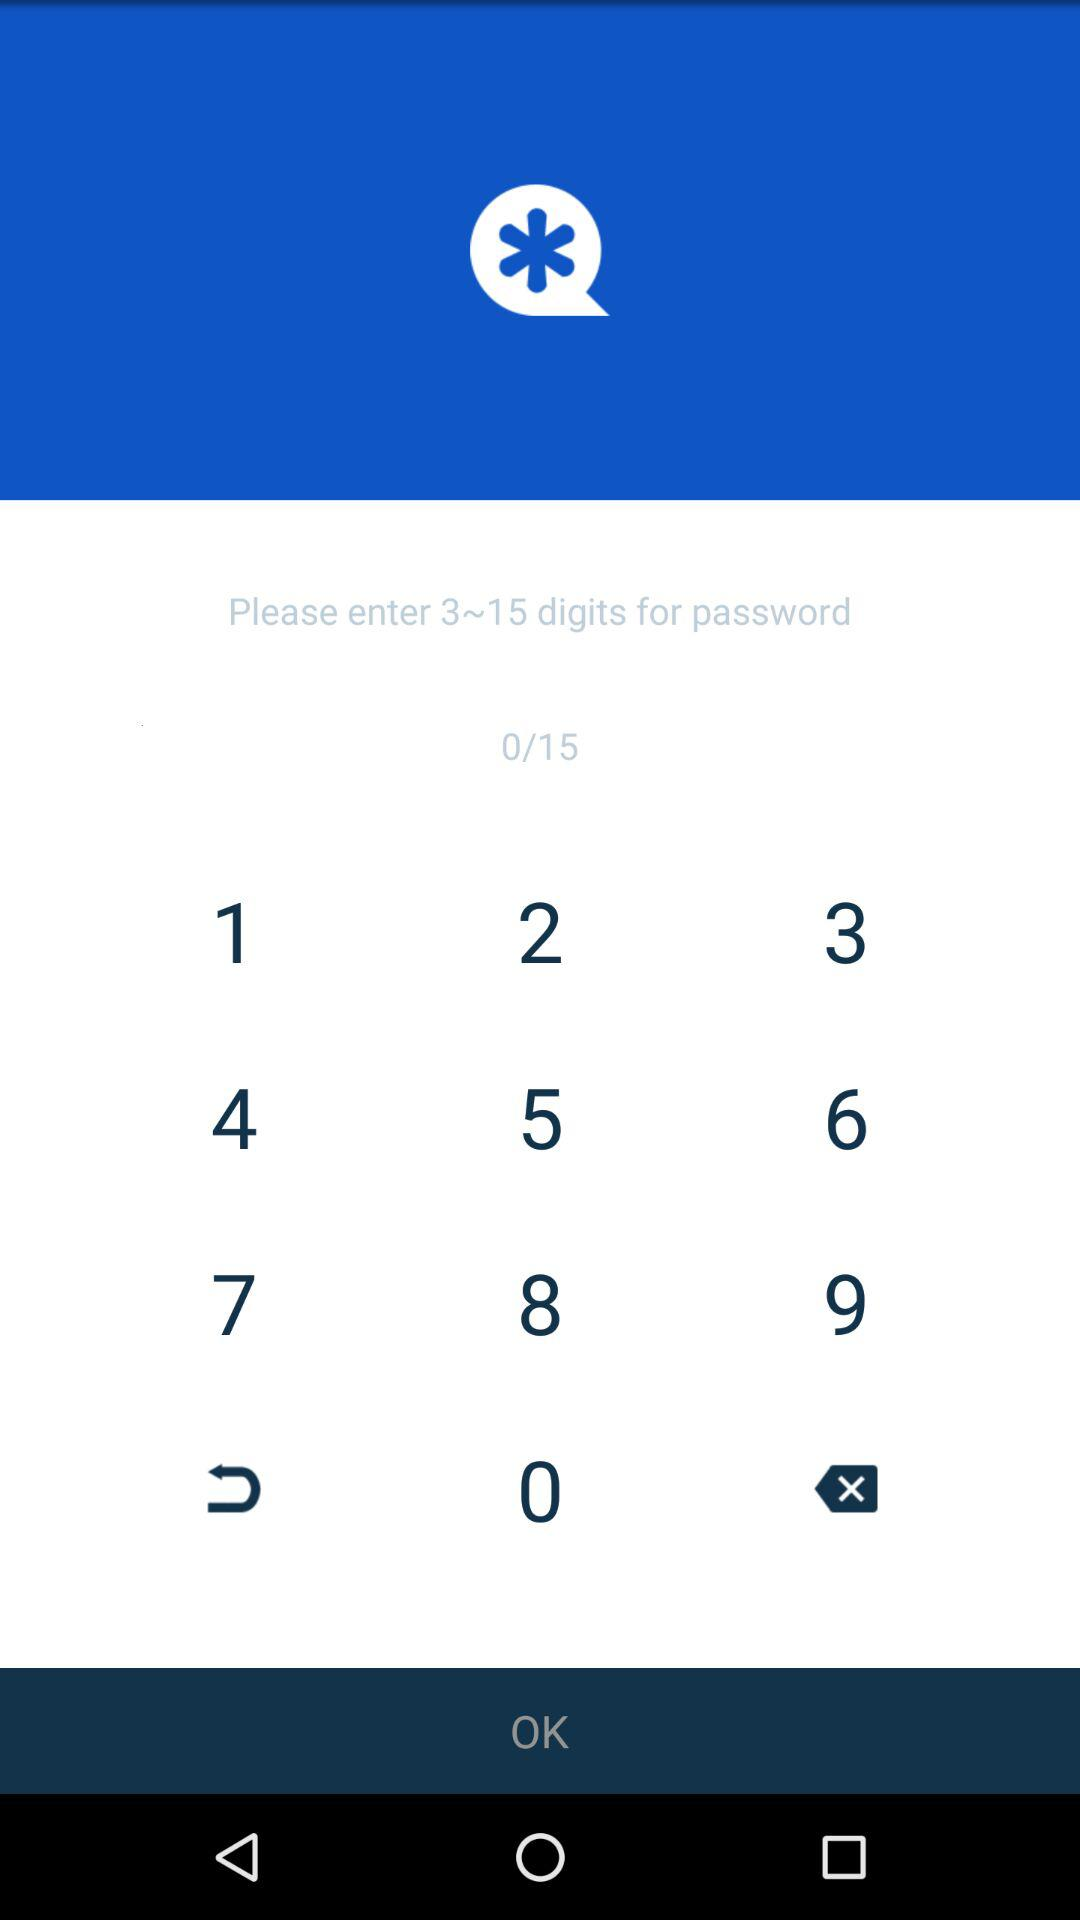What is the digit range for a password? The digit range for a password is 3 to 15. 